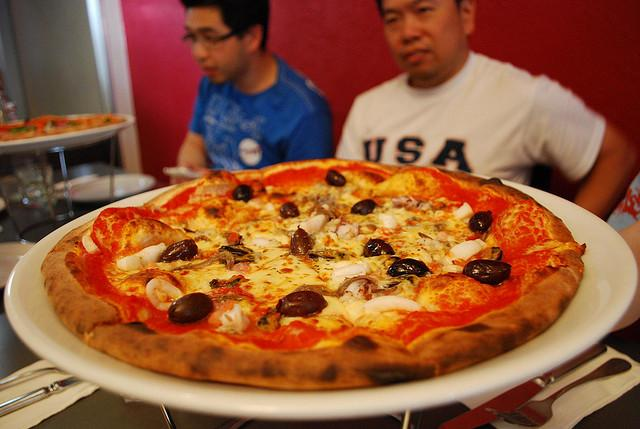What country does the shirt on the right mention? usa 